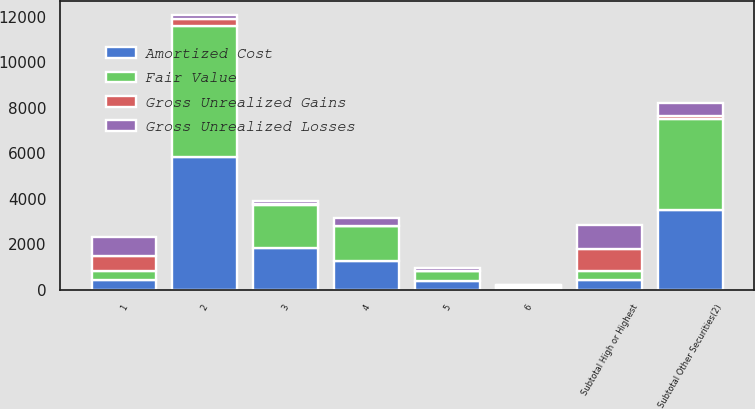Convert chart to OTSL. <chart><loc_0><loc_0><loc_500><loc_500><stacked_bar_chart><ecel><fcel>1<fcel>2<fcel>Subtotal High or Highest<fcel>3<fcel>4<fcel>5<fcel>6<fcel>Subtotal Other Securities(2)<nl><fcel>Fair Value<fcel>407<fcel>5732<fcel>407<fcel>1903<fcel>1552<fcel>460<fcel>77<fcel>3992<nl><fcel>Gross Unrealized Gains<fcel>656<fcel>308<fcel>964<fcel>56<fcel>20<fcel>19<fcel>22<fcel>117<nl><fcel>Gross Unrealized Losses<fcel>853<fcel>187<fcel>1040<fcel>133<fcel>334<fcel>125<fcel>10<fcel>602<nl><fcel>Amortized Cost<fcel>407<fcel>5853<fcel>407<fcel>1826<fcel>1238<fcel>354<fcel>89<fcel>3507<nl></chart> 